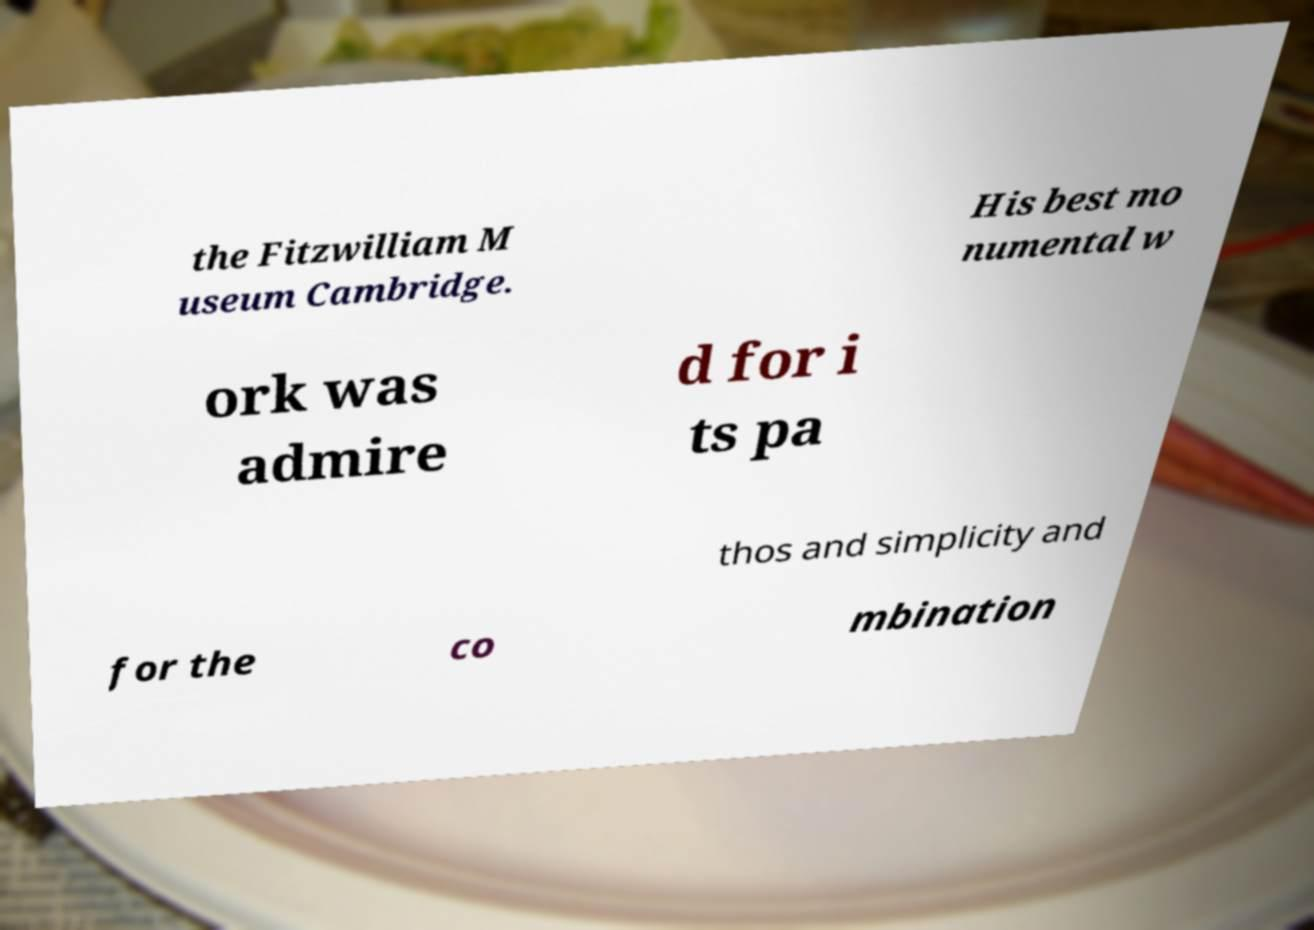Can you read and provide the text displayed in the image?This photo seems to have some interesting text. Can you extract and type it out for me? the Fitzwilliam M useum Cambridge. His best mo numental w ork was admire d for i ts pa thos and simplicity and for the co mbination 